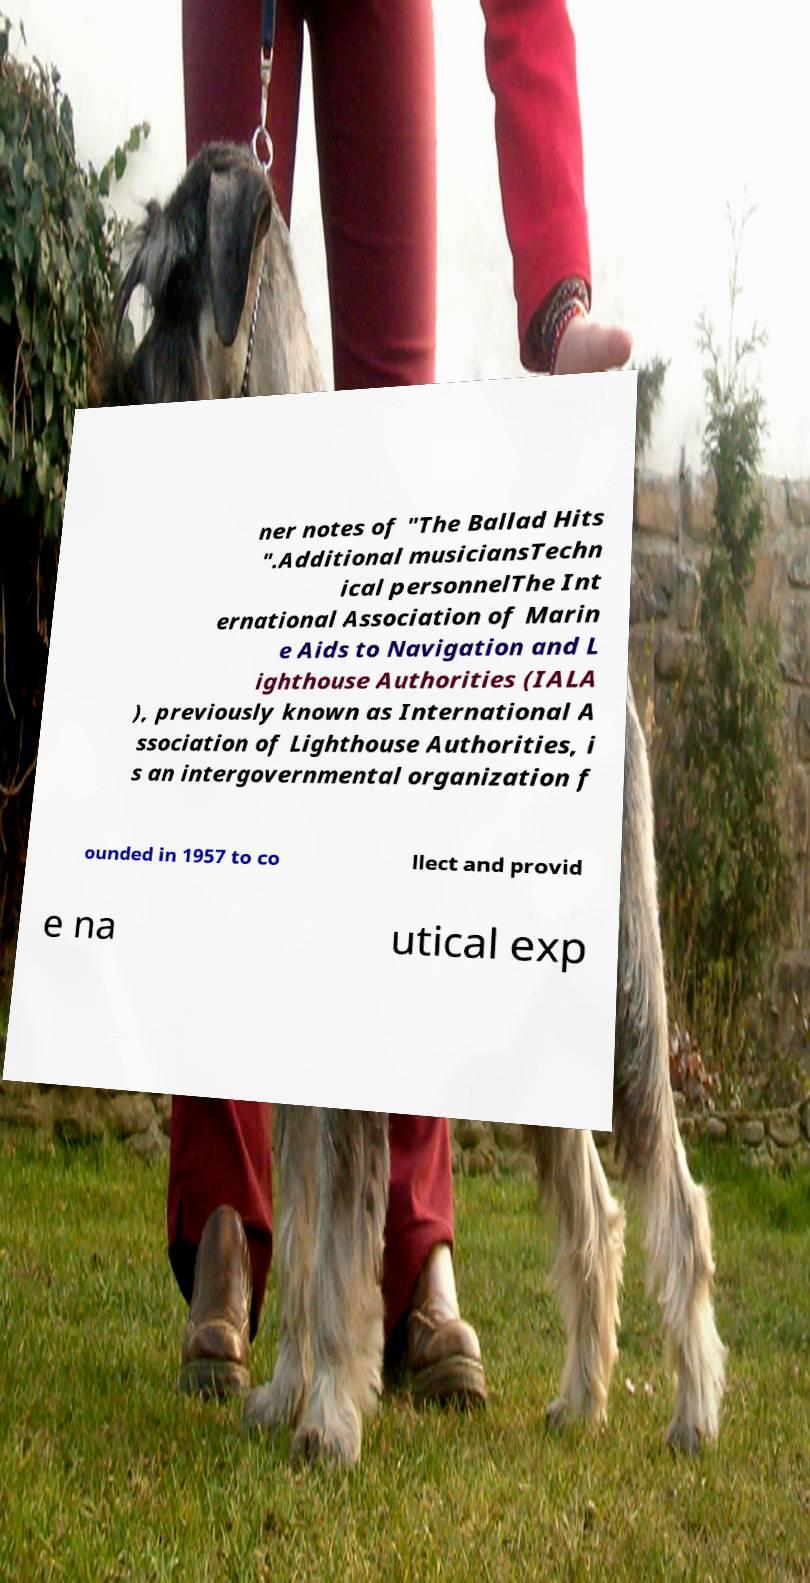Could you assist in decoding the text presented in this image and type it out clearly? ner notes of "The Ballad Hits ".Additional musiciansTechn ical personnelThe Int ernational Association of Marin e Aids to Navigation and L ighthouse Authorities (IALA ), previously known as International A ssociation of Lighthouse Authorities, i s an intergovernmental organization f ounded in 1957 to co llect and provid e na utical exp 